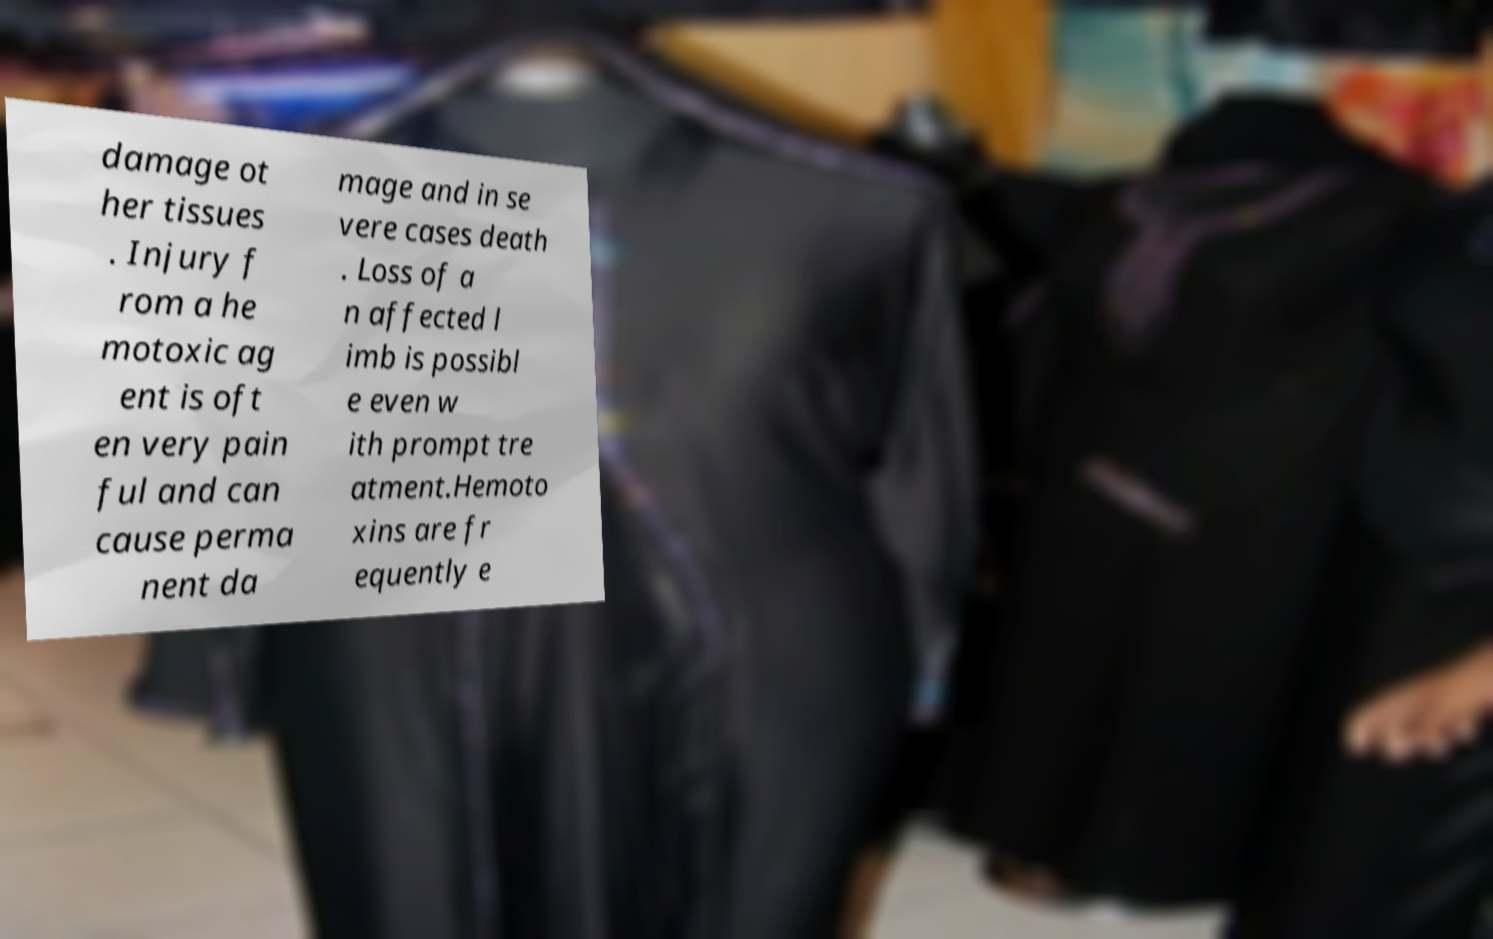Please identify and transcribe the text found in this image. damage ot her tissues . Injury f rom a he motoxic ag ent is oft en very pain ful and can cause perma nent da mage and in se vere cases death . Loss of a n affected l imb is possibl e even w ith prompt tre atment.Hemoto xins are fr equently e 